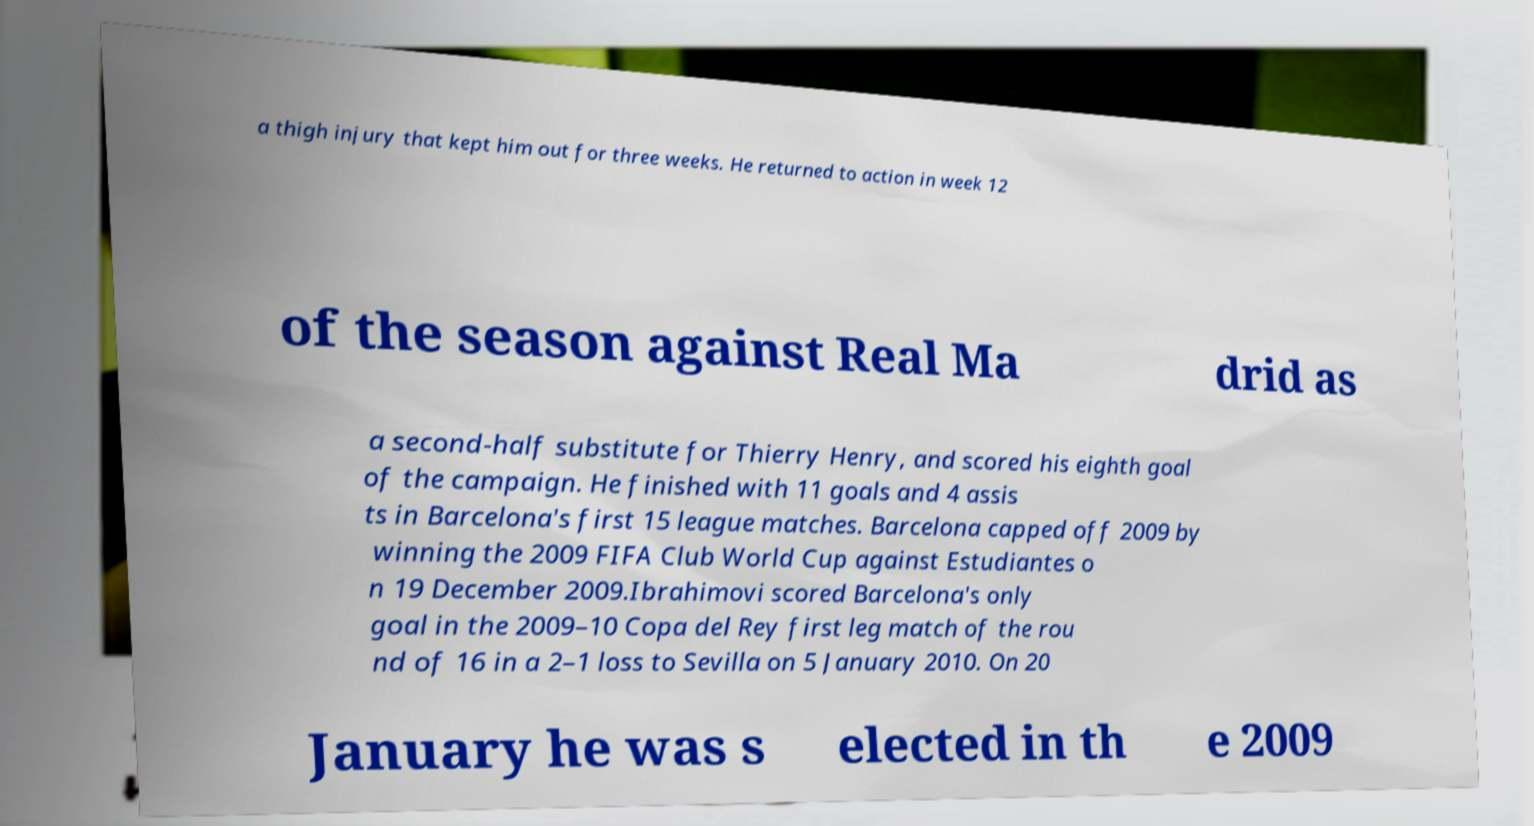What messages or text are displayed in this image? I need them in a readable, typed format. a thigh injury that kept him out for three weeks. He returned to action in week 12 of the season against Real Ma drid as a second-half substitute for Thierry Henry, and scored his eighth goal of the campaign. He finished with 11 goals and 4 assis ts in Barcelona's first 15 league matches. Barcelona capped off 2009 by winning the 2009 FIFA Club World Cup against Estudiantes o n 19 December 2009.Ibrahimovi scored Barcelona's only goal in the 2009–10 Copa del Rey first leg match of the rou nd of 16 in a 2–1 loss to Sevilla on 5 January 2010. On 20 January he was s elected in th e 2009 